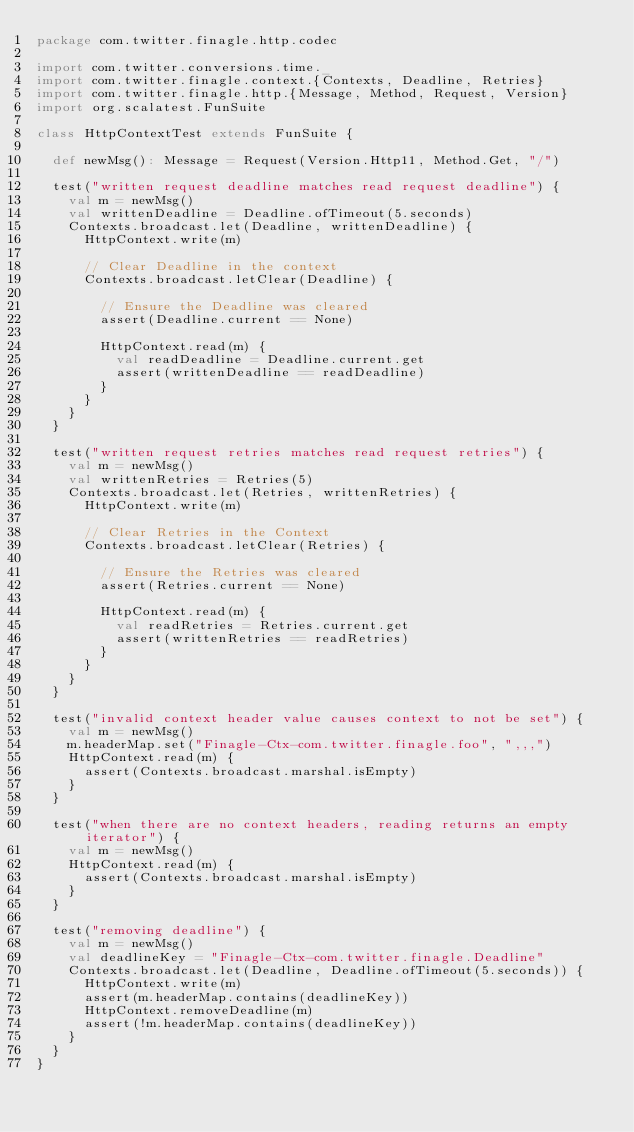Convert code to text. <code><loc_0><loc_0><loc_500><loc_500><_Scala_>package com.twitter.finagle.http.codec

import com.twitter.conversions.time._
import com.twitter.finagle.context.{Contexts, Deadline, Retries}
import com.twitter.finagle.http.{Message, Method, Request, Version}
import org.scalatest.FunSuite

class HttpContextTest extends FunSuite {

  def newMsg(): Message = Request(Version.Http11, Method.Get, "/")

  test("written request deadline matches read request deadline") {
    val m = newMsg()
    val writtenDeadline = Deadline.ofTimeout(5.seconds)
    Contexts.broadcast.let(Deadline, writtenDeadline) {
      HttpContext.write(m)

      // Clear Deadline in the context
      Contexts.broadcast.letClear(Deadline) {

        // Ensure the Deadline was cleared
        assert(Deadline.current == None)

        HttpContext.read(m) {
          val readDeadline = Deadline.current.get
          assert(writtenDeadline == readDeadline)
        }
      }
    }
  }

  test("written request retries matches read request retries") {
    val m = newMsg()
    val writtenRetries = Retries(5)
    Contexts.broadcast.let(Retries, writtenRetries) {
      HttpContext.write(m)

      // Clear Retries in the Context
      Contexts.broadcast.letClear(Retries) {

        // Ensure the Retries was cleared
        assert(Retries.current == None)

        HttpContext.read(m) {
          val readRetries = Retries.current.get
          assert(writtenRetries == readRetries)
        }
      }
    }
  }

  test("invalid context header value causes context to not be set") {
    val m = newMsg()
    m.headerMap.set("Finagle-Ctx-com.twitter.finagle.foo", ",,,")
    HttpContext.read(m) {
      assert(Contexts.broadcast.marshal.isEmpty)
    }
  }

  test("when there are no context headers, reading returns an empty iterator") {
    val m = newMsg()
    HttpContext.read(m) {
      assert(Contexts.broadcast.marshal.isEmpty)
    }
  }

  test("removing deadline") {
    val m = newMsg()
    val deadlineKey = "Finagle-Ctx-com.twitter.finagle.Deadline"
    Contexts.broadcast.let(Deadline, Deadline.ofTimeout(5.seconds)) {
      HttpContext.write(m)
      assert(m.headerMap.contains(deadlineKey))
      HttpContext.removeDeadline(m)
      assert(!m.headerMap.contains(deadlineKey))
    }
  }
}
</code> 